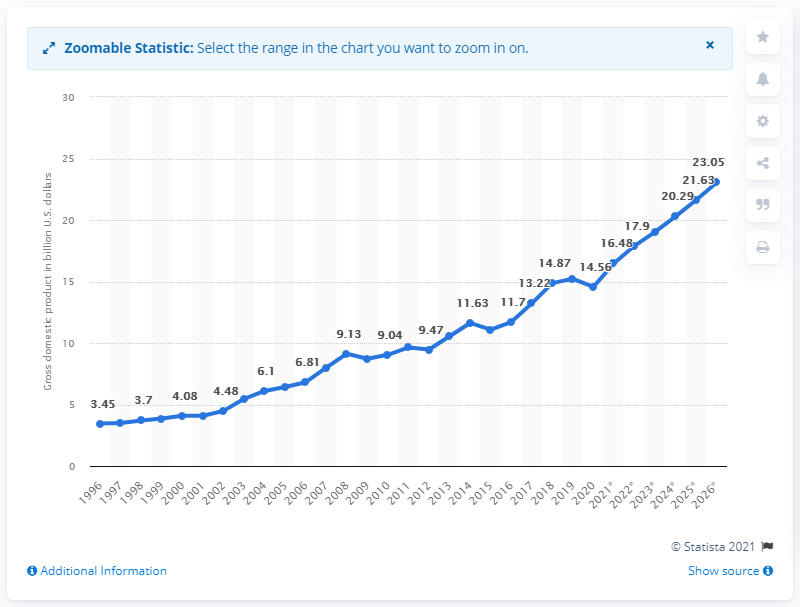Outline some significant characteristics in this image. In 2020, the gross domestic product of Malta was 14.56 billion dollars. 